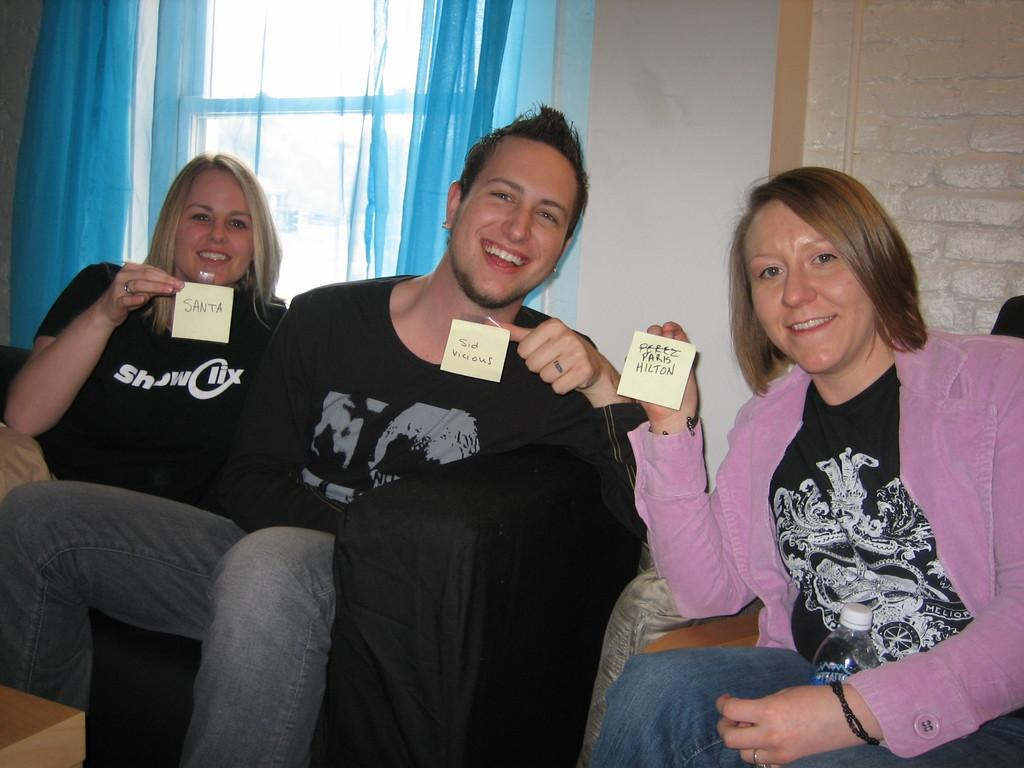What are the people in the image doing? The people in the image are sitting on sofas. What are the people holding in the image? The people are holding name tags. What can be seen in the background of the image? There is a wall and a window in the background of the image. What type of window treatment is present in the image? There are curtains associated with the window. What time does the clock on the wall show in the image? There is no clock visible in the image. Can you describe the cat sitting on the sofa with the people? There is no cat present in the image; only people sitting on sofas are visible. 